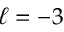<formula> <loc_0><loc_0><loc_500><loc_500>\ell = - 3</formula> 